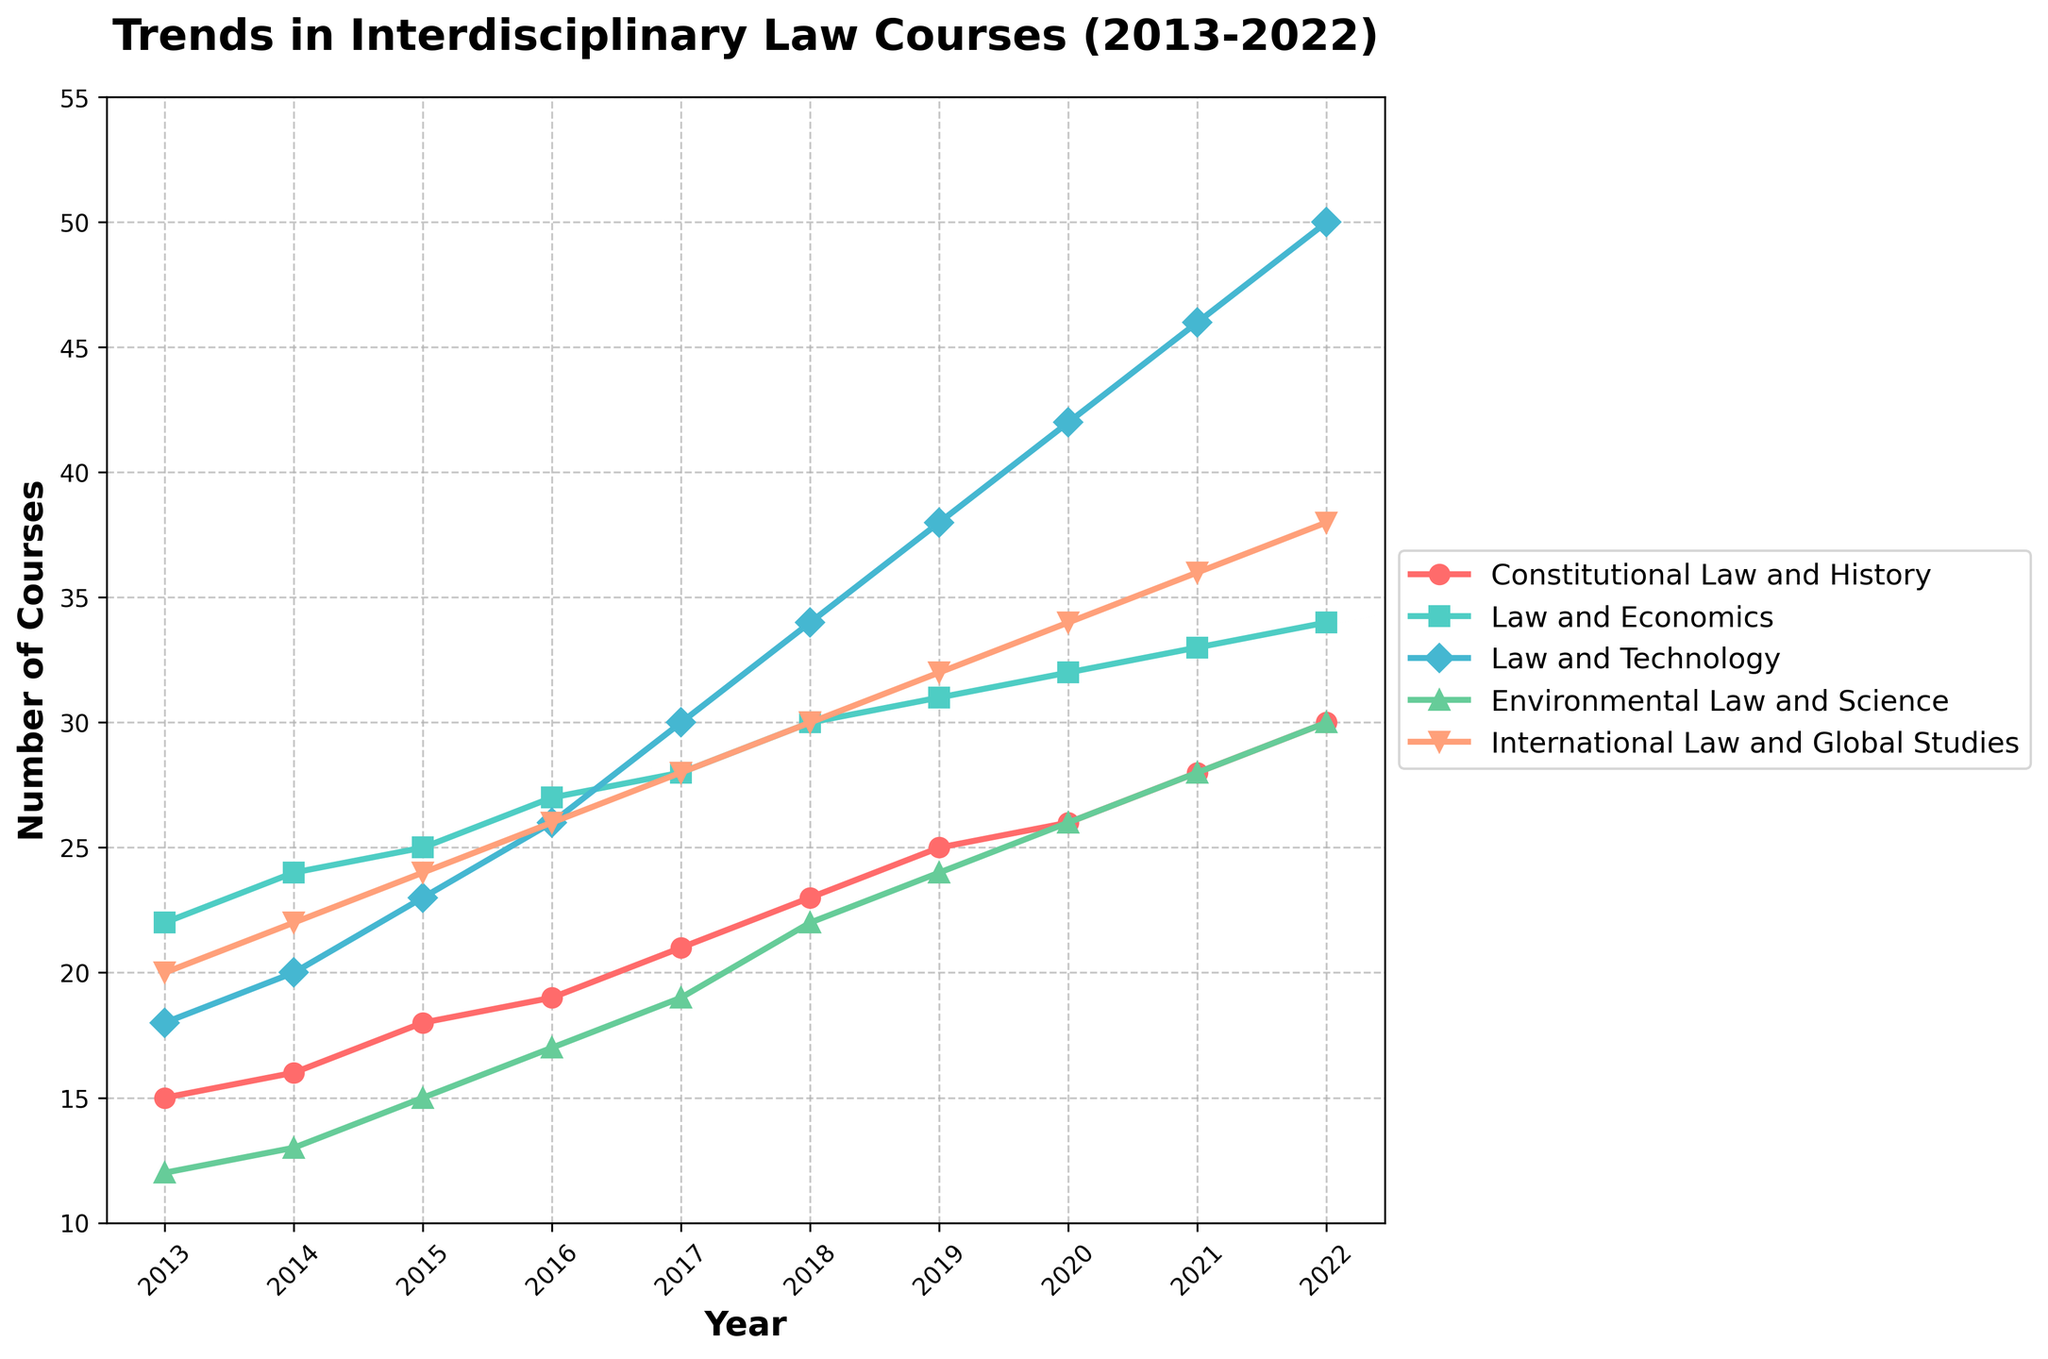what trends can be observed for the Law and Technology course over the analyzed period? The Law and Technology course shows a consistent increase in the number of courses offered every year from 2013 (18 courses) to 2022 (50 courses). This indicates growing interest and investment in integrating technology with law.
Answer: Consistent increase Which course had the highest number of offerings in 2022? By comparing the endpoints of the lines in 2022, we see that the Law and Technology course had the highest number of offerings at 50.
Answer: Law and Technology Which course had a lower number of offerings in 2014 compared to 2013? Comparing the number of offerings from 2013 to 2014 for each course, it's clear that all courses show an increase in their values, so none of the courses had a lower number of offerings in 2014 compared to 2013.
Answer: None What is the average number of Constitutional Law and History courses offered from 2013 to 2022? Summing the data points for Constitutional Law and History from 2013 to 2022 (15+16+18+19+21+23+25+26+28+30) gives a total of 221. Dividing this by 10 (number of years) results in an average of 22.1 courses.
Answer: 22.1 How many more International Law and Global Studies courses were offered in 2022 compared to 2013? In 2013, there were 20 International Law and Global Studies courses. In 2022, there were 38. The difference is 38 - 20 = 18 courses.
Answer: 18 Which course had the highest growth rate between 2013 and 2022? To find the course with the highest growth rate, look at the increase in the number of offerings from 2013 to 2022 for each course: 
- Constitutional Law and History: 30 - 15 = 15 
- Law and Economics: 34 - 22 = 12 
- Law and Technology: 50 - 18 = 32 
- Environmental Law and Science: 30 - 12 = 18 
- International Law and Global Studies: 38 - 20 = 18 
The Law and Technology course shows the highest growth rate with an increase of 32 courses.
Answer: Law and Technology Which courses had similar trends in growth from 2013 to 2022 and how can you tell? Environmental Law and Science and International Law and Global Studies had similar trends. They both started close in values (Environmental Law at 12 and International Law at 20) and ended close in values (Environmental Law at 30 and International Law at 38). Both lines show a similar pace of increase and consistency in growth.
Answer: Environmental Law and Science and International Law and Global Studies What was the total number of interdisciplinary law courses offered across all categories in 2017? Summing the values in 2017 for all courses: 21 (Constitutional Law and History) + 28 (Law and Economics) + 30 (Law and Technology) + 19 (Environmental Law and Science) + 28 (International Law and Global Studies) = 126 courses.
Answer: 126 Which year did Environmental Law and Science see the highest annual increase in the number of courses offered? To find the highest annual increase, compute the difference for each year:
- 2014: 13 - 12 = 1 
- 2015: 15 - 13 = 2 
- 2016: 17 - 15 = 2 
- 2017: 19 - 17 = 2 
- 2018: 22 - 19 = 3 
- 2019: 24 - 22 = 2 
- 2020: 26 - 24 = 2 
- 2021: 28 - 26 = 2 
- 2022: 30 - 28 = 2 
2018 shows the highest annual increase with a change of 3.
Answer: 2018 